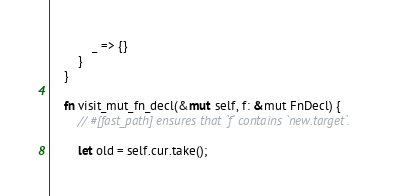<code> <loc_0><loc_0><loc_500><loc_500><_Rust_>
            _ => {}
        }
    }

    fn visit_mut_fn_decl(&mut self, f: &mut FnDecl) {
        // #[fast_path] ensures that `f` contains `new.target`.

        let old = self.cur.take();</code> 